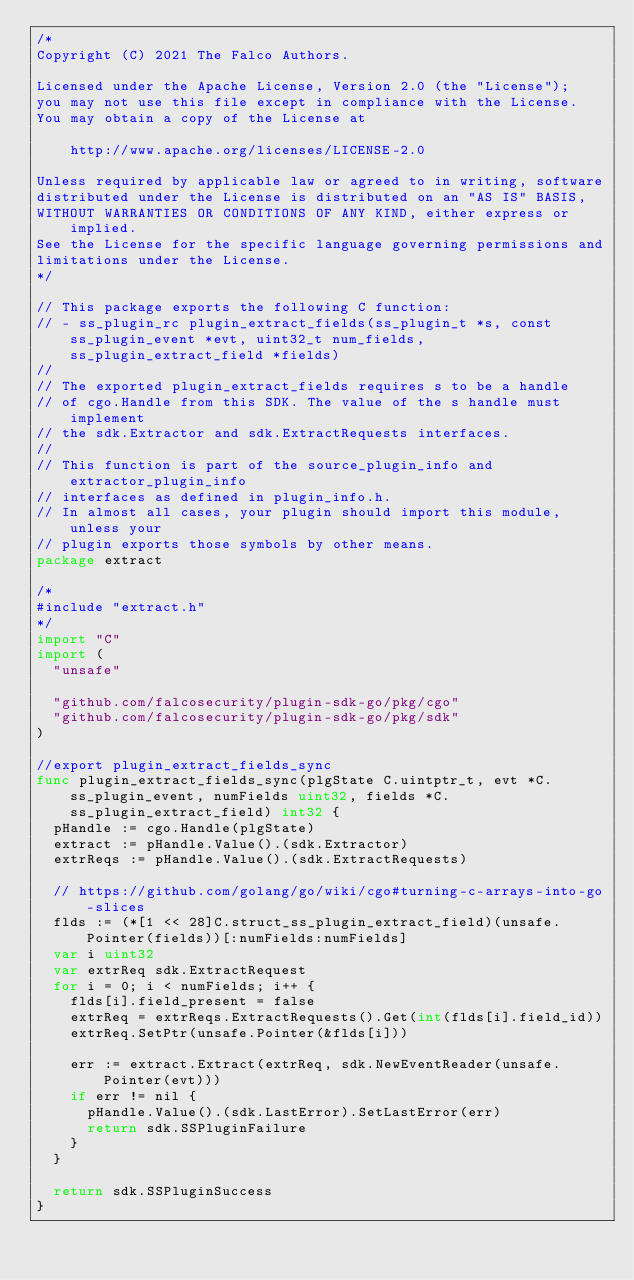Convert code to text. <code><loc_0><loc_0><loc_500><loc_500><_Go_>/*
Copyright (C) 2021 The Falco Authors.

Licensed under the Apache License, Version 2.0 (the "License");
you may not use this file except in compliance with the License.
You may obtain a copy of the License at

    http://www.apache.org/licenses/LICENSE-2.0

Unless required by applicable law or agreed to in writing, software
distributed under the License is distributed on an "AS IS" BASIS,
WITHOUT WARRANTIES OR CONDITIONS OF ANY KIND, either express or implied.
See the License for the specific language governing permissions and
limitations under the License.
*/

// This package exports the following C function:
// - ss_plugin_rc plugin_extract_fields(ss_plugin_t *s, const ss_plugin_event *evt, uint32_t num_fields, ss_plugin_extract_field *fields)
//
// The exported plugin_extract_fields requires s to be a handle
// of cgo.Handle from this SDK. The value of the s handle must implement
// the sdk.Extractor and sdk.ExtractRequests interfaces.
//
// This function is part of the source_plugin_info and extractor_plugin_info
// interfaces as defined in plugin_info.h.
// In almost all cases, your plugin should import this module, unless your
// plugin exports those symbols by other means.
package extract

/*
#include "extract.h"
*/
import "C"
import (
	"unsafe"

	"github.com/falcosecurity/plugin-sdk-go/pkg/cgo"
	"github.com/falcosecurity/plugin-sdk-go/pkg/sdk"
)

//export plugin_extract_fields_sync
func plugin_extract_fields_sync(plgState C.uintptr_t, evt *C.ss_plugin_event, numFields uint32, fields *C.ss_plugin_extract_field) int32 {
	pHandle := cgo.Handle(plgState)
	extract := pHandle.Value().(sdk.Extractor)
	extrReqs := pHandle.Value().(sdk.ExtractRequests)

	// https://github.com/golang/go/wiki/cgo#turning-c-arrays-into-go-slices
	flds := (*[1 << 28]C.struct_ss_plugin_extract_field)(unsafe.Pointer(fields))[:numFields:numFields]
	var i uint32
	var extrReq sdk.ExtractRequest
	for i = 0; i < numFields; i++ {
		flds[i].field_present = false
		extrReq = extrReqs.ExtractRequests().Get(int(flds[i].field_id))
		extrReq.SetPtr(unsafe.Pointer(&flds[i]))

		err := extract.Extract(extrReq, sdk.NewEventReader(unsafe.Pointer(evt)))
		if err != nil {
			pHandle.Value().(sdk.LastError).SetLastError(err)
			return sdk.SSPluginFailure
		}
	}

	return sdk.SSPluginSuccess
}
</code> 